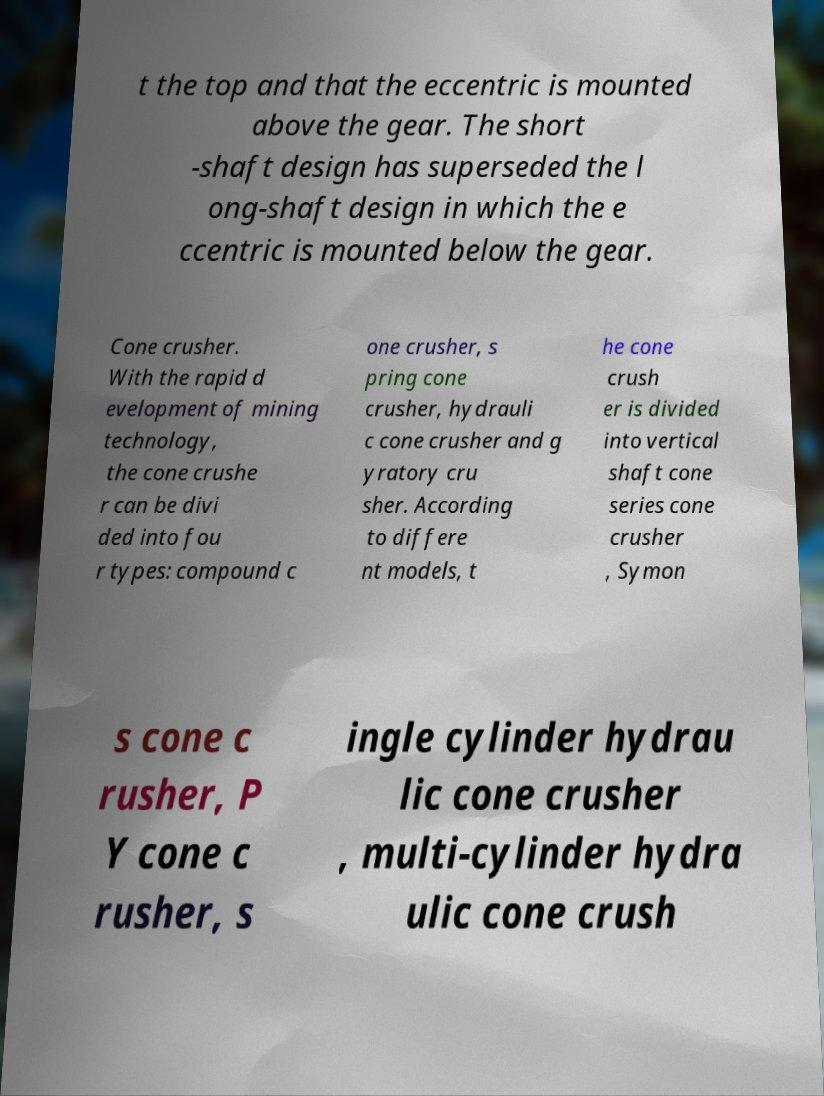Please identify and transcribe the text found in this image. t the top and that the eccentric is mounted above the gear. The short -shaft design has superseded the l ong-shaft design in which the e ccentric is mounted below the gear. Cone crusher. With the rapid d evelopment of mining technology, the cone crushe r can be divi ded into fou r types: compound c one crusher, s pring cone crusher, hydrauli c cone crusher and g yratory cru sher. According to differe nt models, t he cone crush er is divided into vertical shaft cone series cone crusher , Symon s cone c rusher, P Y cone c rusher, s ingle cylinder hydrau lic cone crusher , multi-cylinder hydra ulic cone crush 